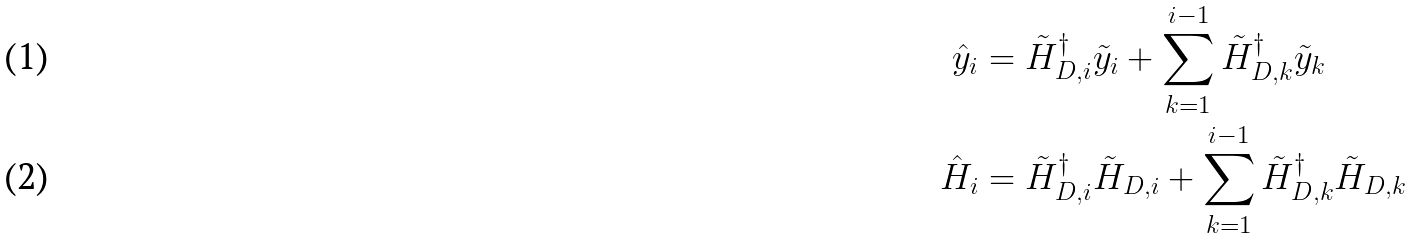<formula> <loc_0><loc_0><loc_500><loc_500>\hat { y } _ { i } & = \tilde { H } _ { D , i } ^ { \dagger } \tilde { y } _ { i } + \sum _ { k = 1 } ^ { i - 1 } \tilde { H } _ { D , k } ^ { \dagger } \tilde { y } _ { k } \\ \hat { H } _ { i } & = \tilde { H } _ { D , i } ^ { \dagger } \tilde { H } _ { D , i } + \sum _ { k = 1 } ^ { i - 1 } \tilde { H } _ { D , k } ^ { \dagger } \tilde { H } _ { D , k }</formula> 